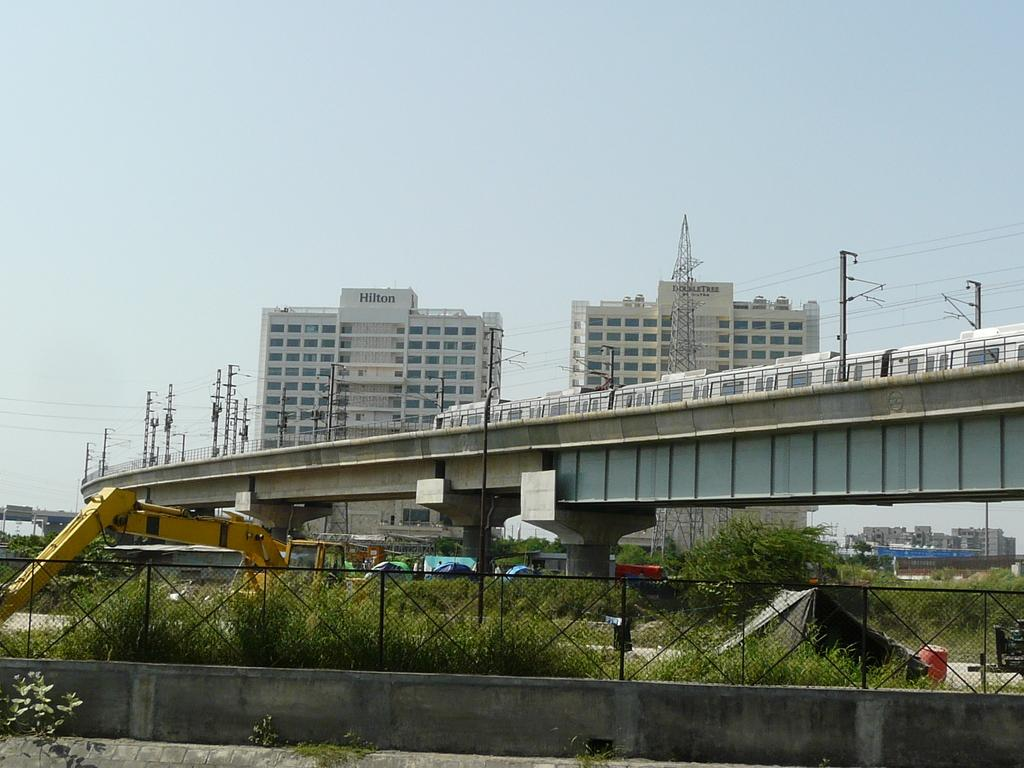What is located at the front of the image? There is a fence in the front of the image. What type of vegetation can be seen in the image? There are plants and a tree in the image. What is the large object with a long neck in the image? There is a crane in the image. What mode of transportation can be seen in the image? There is a metro on a bridge in the image. How many buildings are visible in the image? There are two buildings in the image. What is visible at the top of the image? The sky is visible at the top of the image. Where are the dolls located in the image? There are no dolls present in the image. What direction does the attack come from in the image? There is no attack or any indication of violence in the image. 